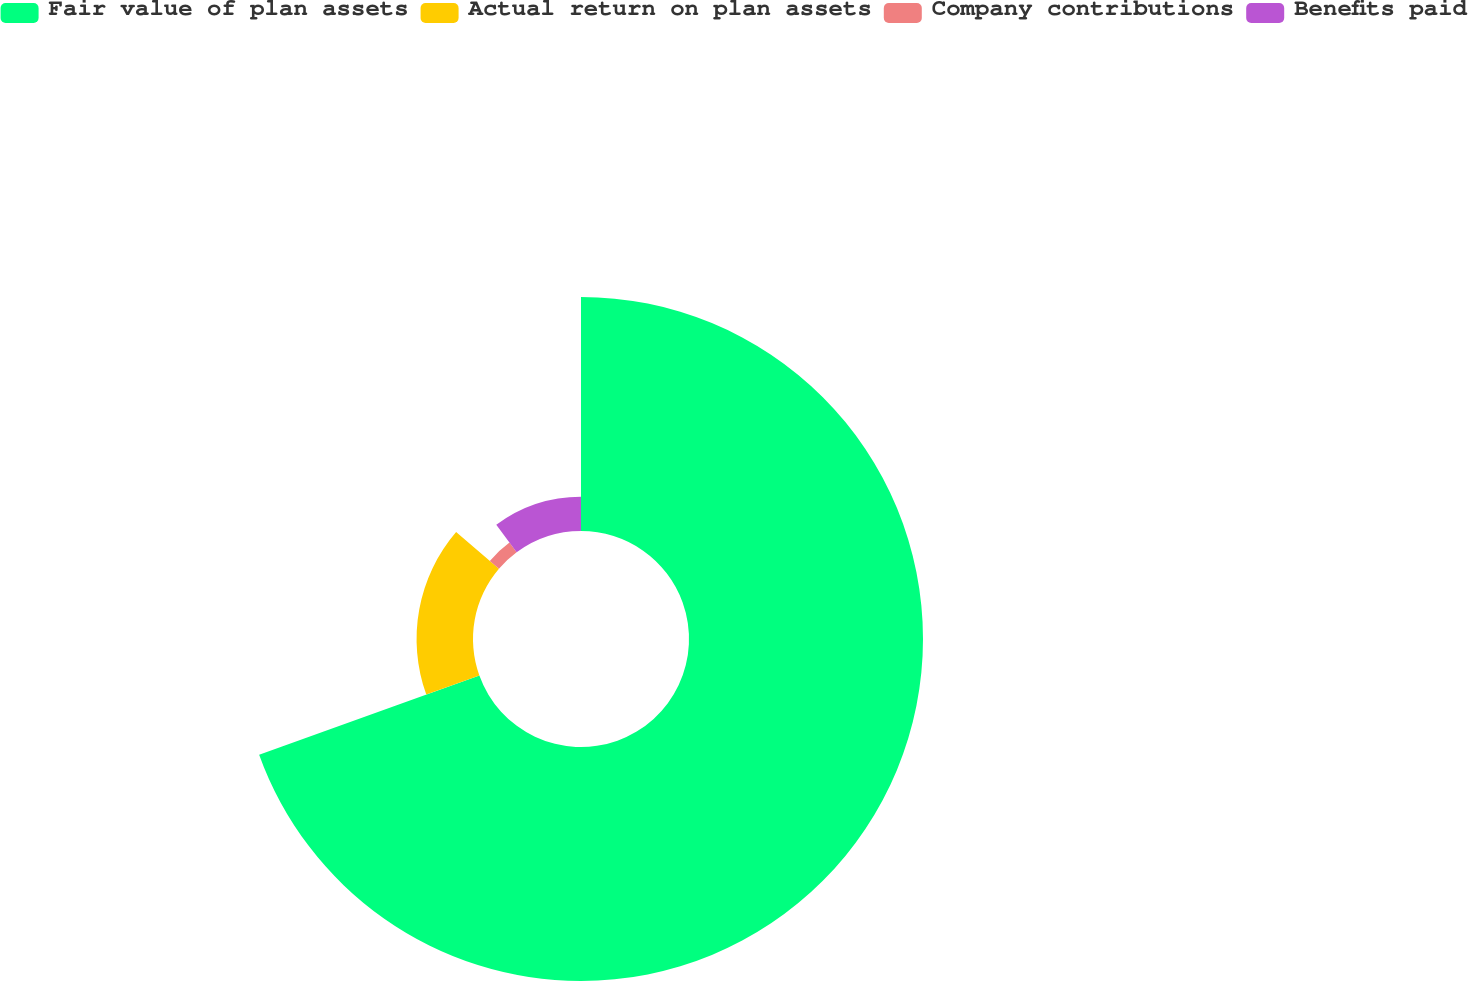Convert chart to OTSL. <chart><loc_0><loc_0><loc_500><loc_500><pie_chart><fcel>Fair value of plan assets<fcel>Actual return on plan assets<fcel>Company contributions<fcel>Benefits paid<nl><fcel>69.51%<fcel>16.76%<fcel>3.57%<fcel>10.16%<nl></chart> 